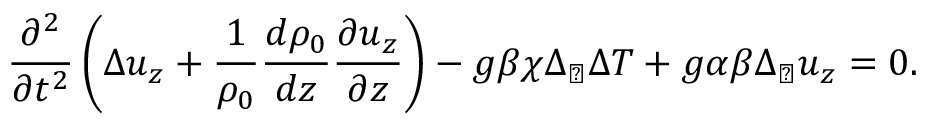<formula> <loc_0><loc_0><loc_500><loc_500>\frac { \partial ^ { 2 } } { \partial t ^ { 2 } } \left ( \Delta u _ { z } + \frac { 1 } { \rho _ { 0 } } \frac { d \rho _ { 0 } } { d z } \frac { \partial u _ { z } } { \partial z } \right ) - g \beta \chi \Delta _ { \perp } \Delta T + g \alpha \beta \Delta _ { \perp } u _ { z } = 0 .</formula> 